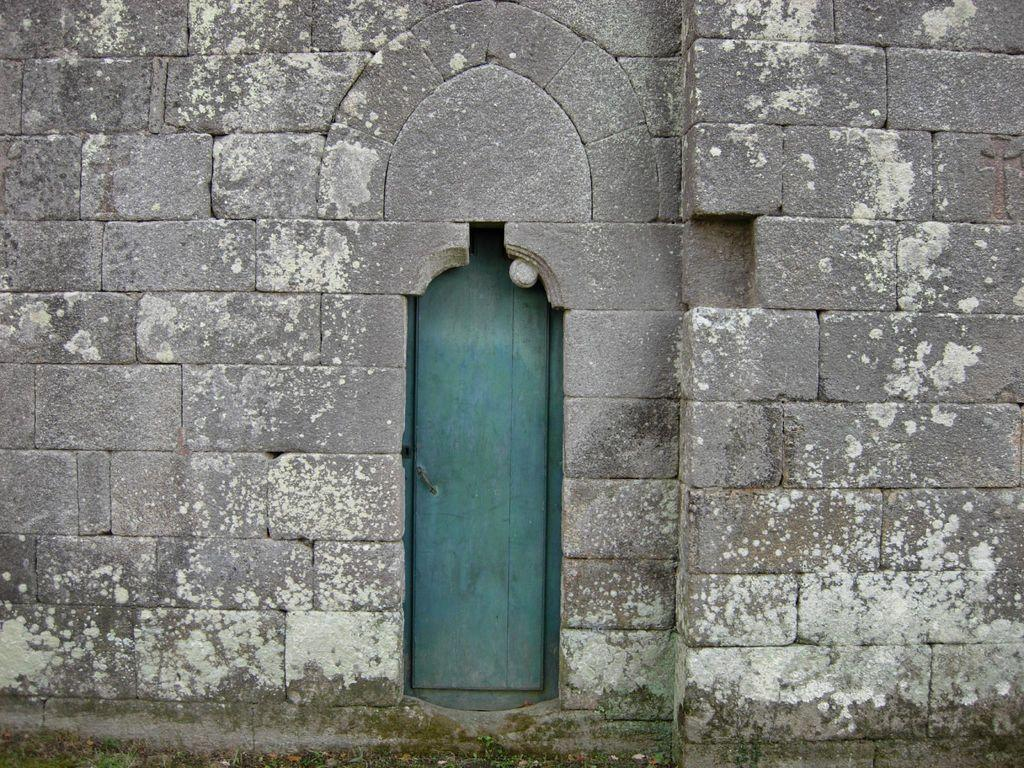What type of structure can be seen in the image? There is a door and a wall in the image. Can you describe the door in the image? The door is a part of the structure and is visible in the image. What else can be seen in the image besides the door? There is also a wall in the image. What type of bone can be seen in the image? There is no bone present in the image; it only shows a door and a wall. 